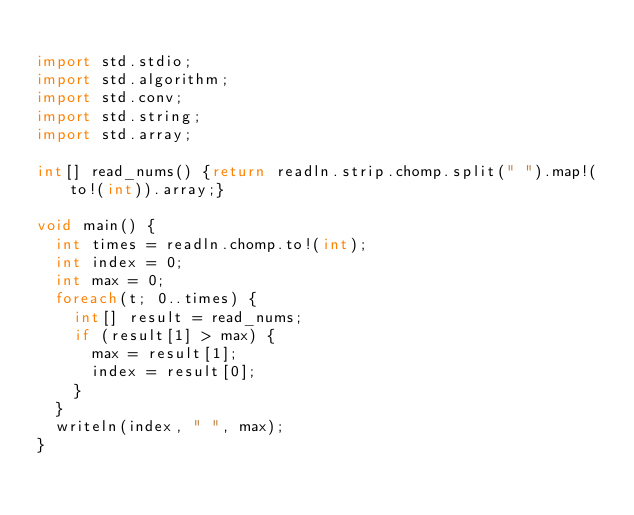<code> <loc_0><loc_0><loc_500><loc_500><_D_>
import std.stdio;
import std.algorithm;
import std.conv;
import std.string;
import std.array;

int[] read_nums() {return readln.strip.chomp.split(" ").map!(to!(int)).array;}

void main() {
  int times = readln.chomp.to!(int);
  int index = 0;
  int max = 0;
  foreach(t; 0..times) {
    int[] result = read_nums;
    if (result[1] > max) {
      max = result[1];
      index = result[0];
    }
  }
  writeln(index, " ", max);
}</code> 